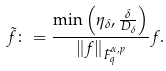Convert formula to latex. <formula><loc_0><loc_0><loc_500><loc_500>\tilde { f } \colon = \frac { \min \left ( \eta _ { \delta } , \frac { \delta } { D _ { \delta } } \right ) } { \left \| f \right \| _ { \dot { F } ^ { \alpha , p } _ { q } } } f .</formula> 